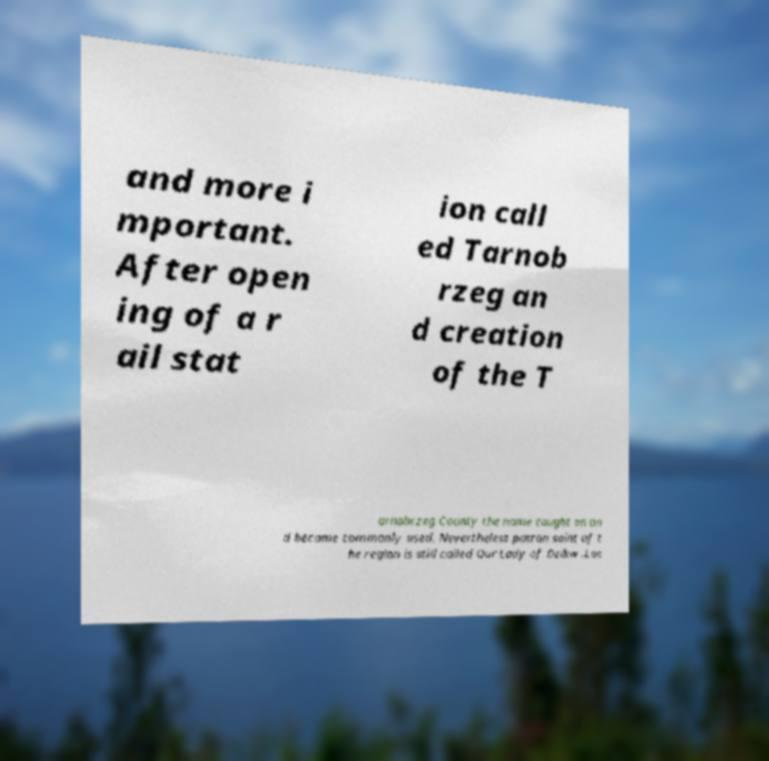Please identify and transcribe the text found in this image. and more i mportant. After open ing of a r ail stat ion call ed Tarnob rzeg an d creation of the T arnobrzeg County the name caught on an d became commonly used. Nevertheless patron saint of t he region is still called Our Lady of Dzikw .Loc 